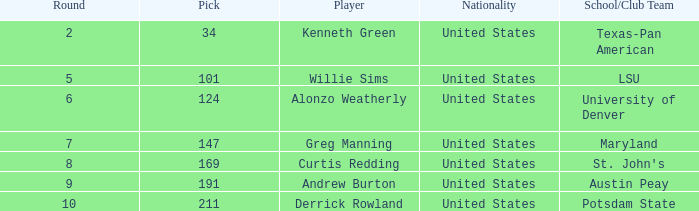What is the average Pick when the round was less than 6 for kenneth green? 34.0. 